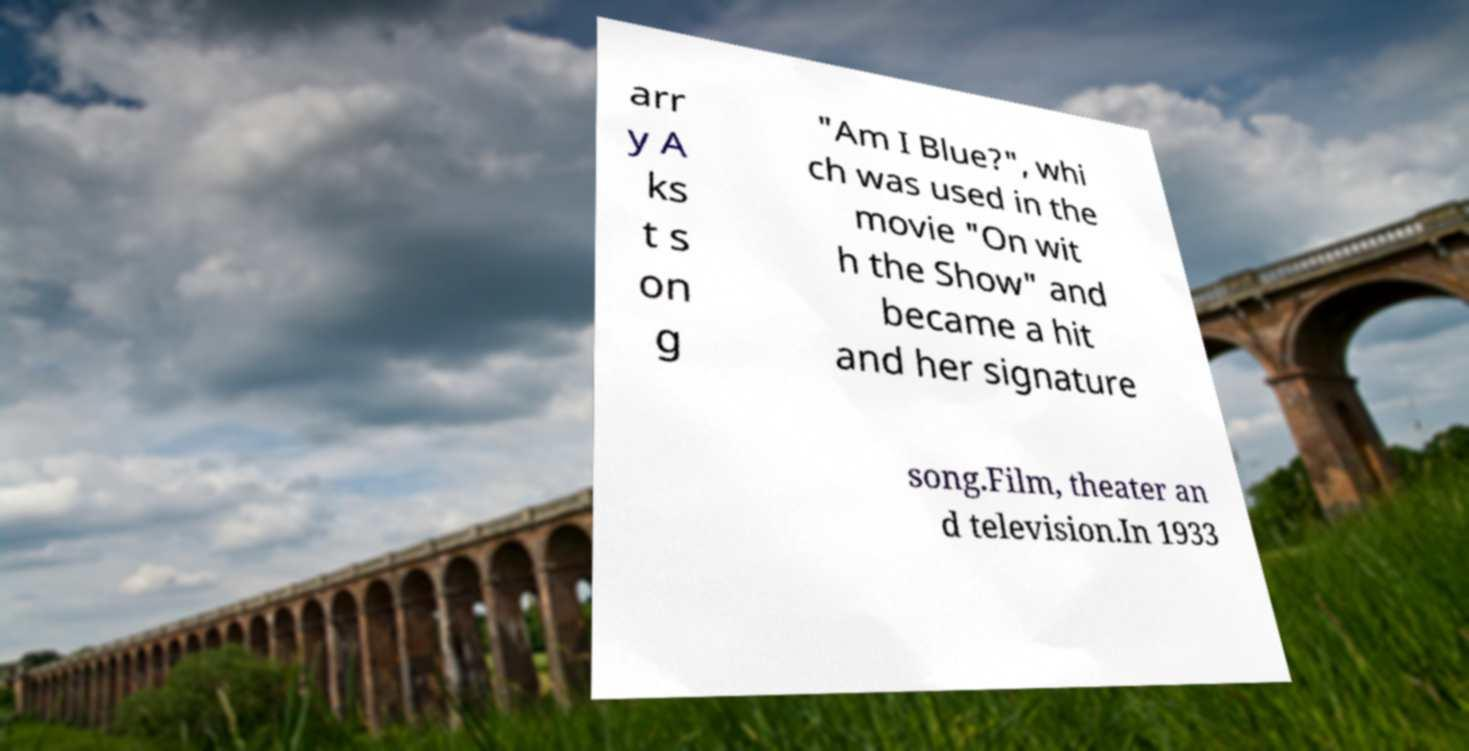I need the written content from this picture converted into text. Can you do that? arr y A ks t s on g "Am I Blue?", whi ch was used in the movie "On wit h the Show" and became a hit and her signature song.Film, theater an d television.In 1933 